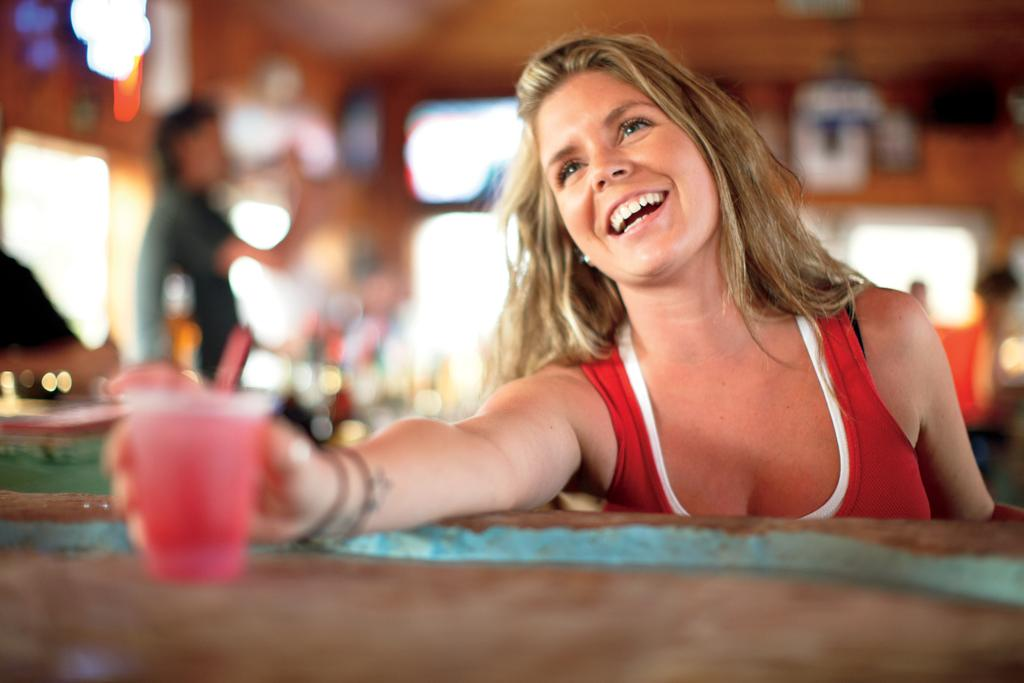What is the hair color of the woman in the image? The woman in the image has blond hair. What is the woman wearing? The woman is wearing a red vest. What is the woman holding in the image? The woman is holding a cup. Where is the woman standing in relation to the table? The woman is standing in front of a table. Can you describe the man in the background? There is a man standing on the left side in the background. How would you describe the background of the image? The background is blurry. How many girls are jumping in the image? There are no girls or jumping depicted in the image. What color is the vein on the woman's forehead? There is no visible vein on the woman's forehead in the image. 